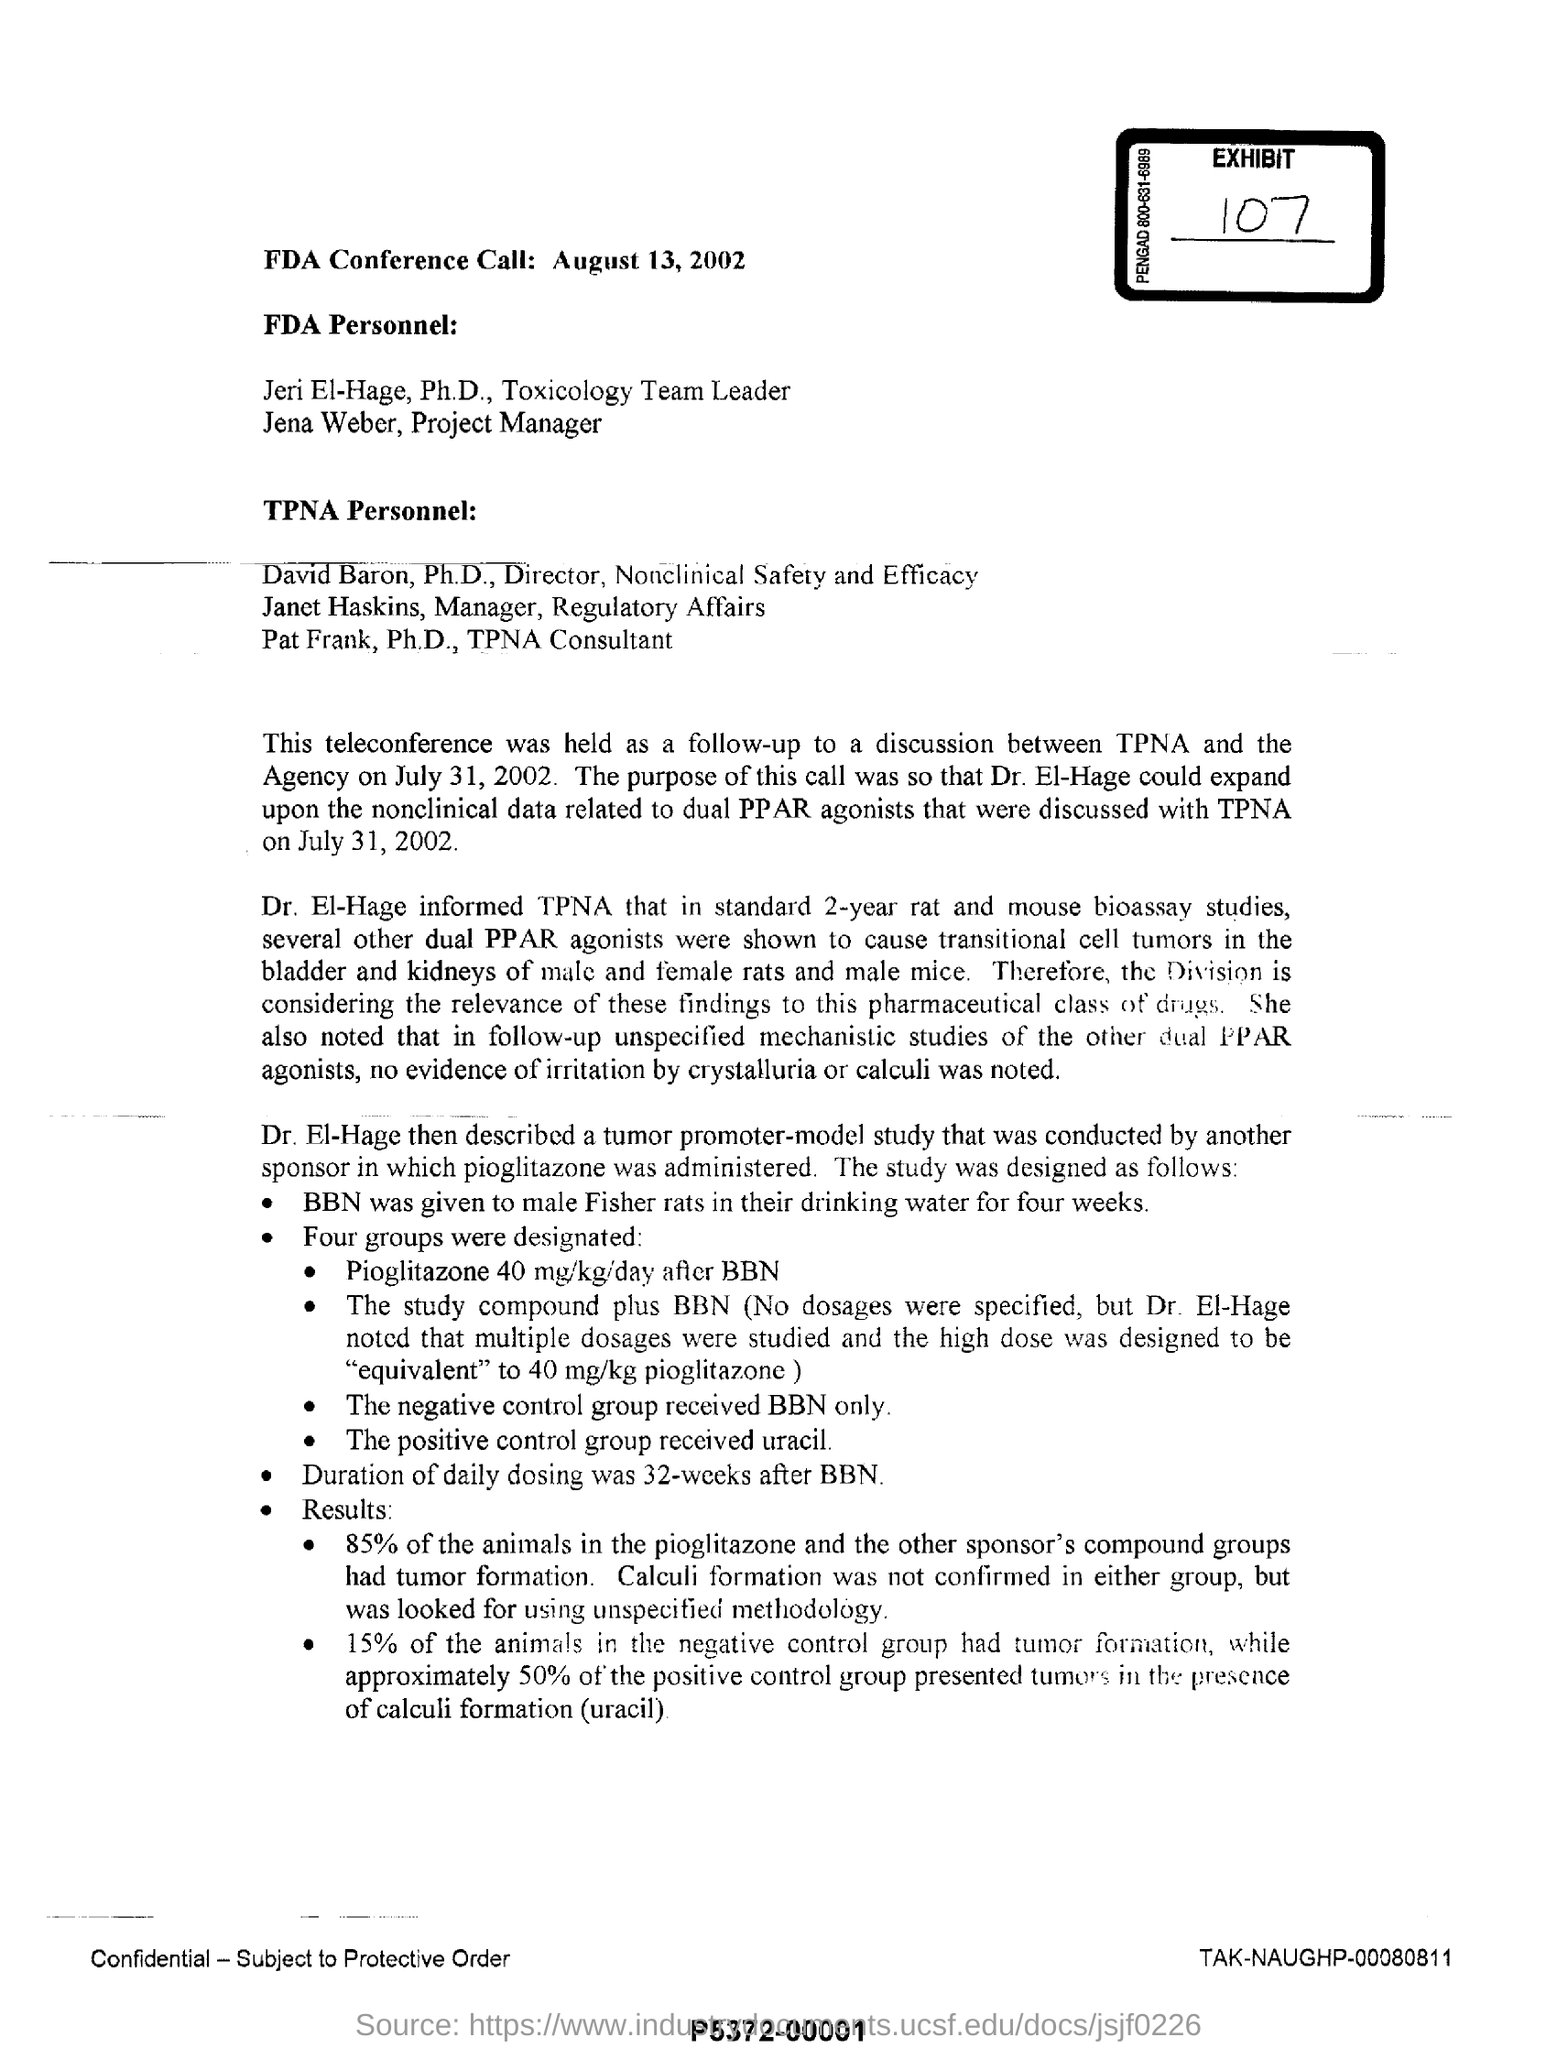What is the issued date of this document?
Make the answer very short. August 13, 2002. Who is the Director of Nonclinical Safety and Efficacy?
Keep it short and to the point. David Baron. Who described tumor promoter-model study?
Provide a succinct answer. Dr.  El-Hage. What is the duration of daily dosing?
Ensure brevity in your answer.  32-weeks after BBN. What is the exhibit number?
Give a very brief answer. 107. 